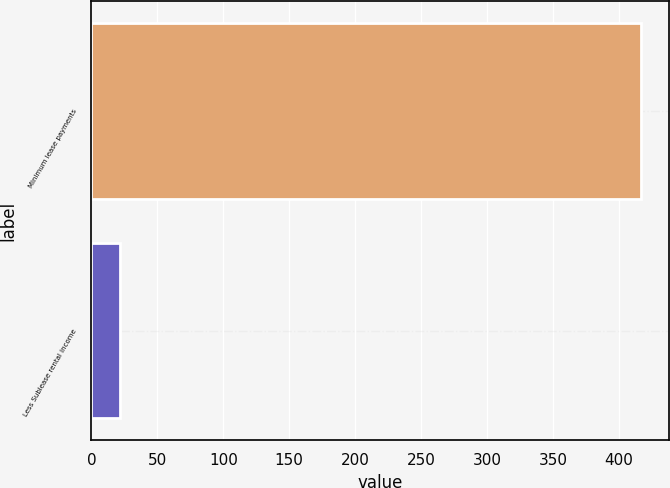Convert chart. <chart><loc_0><loc_0><loc_500><loc_500><bar_chart><fcel>Minimum lease payments<fcel>Less Sublease rental income<nl><fcel>417<fcel>22<nl></chart> 